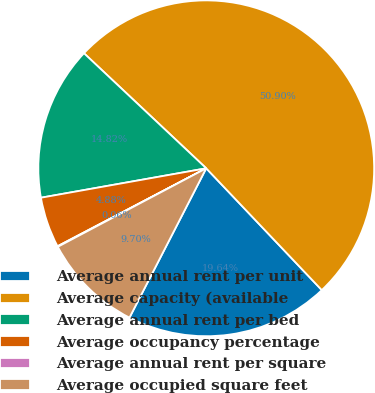Convert chart to OTSL. <chart><loc_0><loc_0><loc_500><loc_500><pie_chart><fcel>Average annual rent per unit<fcel>Average capacity (available<fcel>Average annual rent per bed<fcel>Average occupancy percentage<fcel>Average annual rent per square<fcel>Average occupied square feet<nl><fcel>19.64%<fcel>50.9%<fcel>14.82%<fcel>4.88%<fcel>0.06%<fcel>9.7%<nl></chart> 